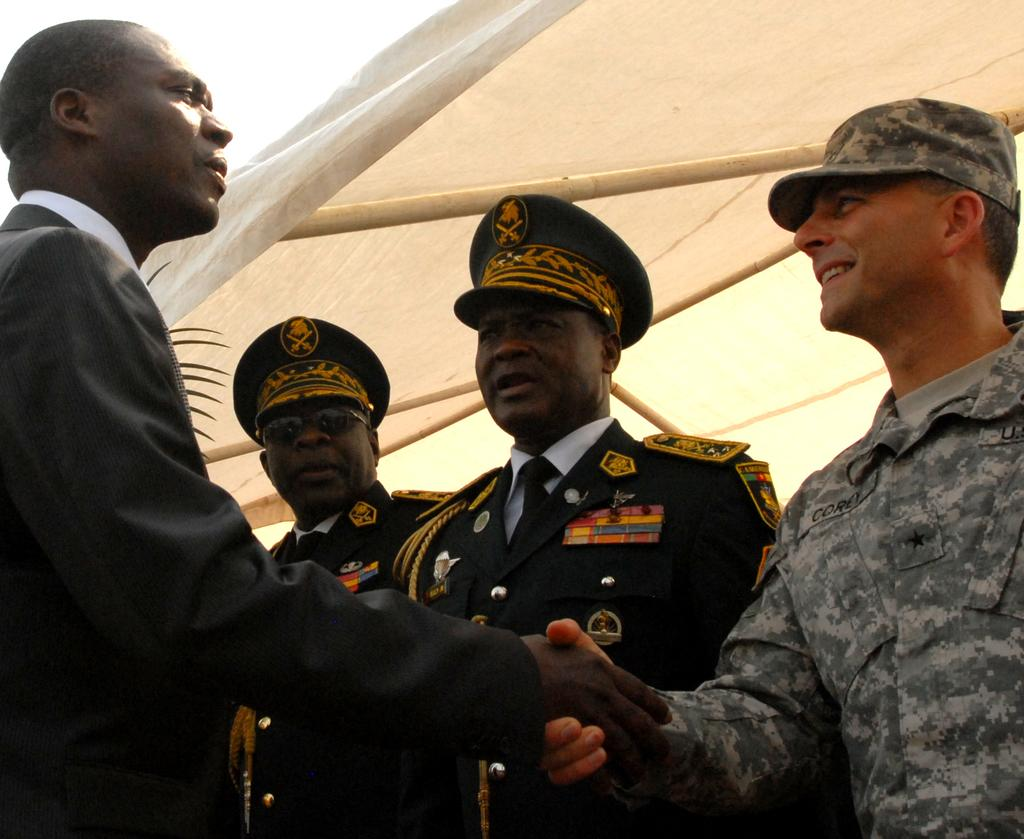What are the men in the image doing? Two men are shaking hands in the image. How many men are present in the image? There are men standing in the image. What structure can be seen in the image? There is a tent in the image. What is visible in the background of the image? The sky is visible in the background of the image. What type of banana is hanging from the tent in the image? There is no banana present in the image, and therefore no such object can be observed. 